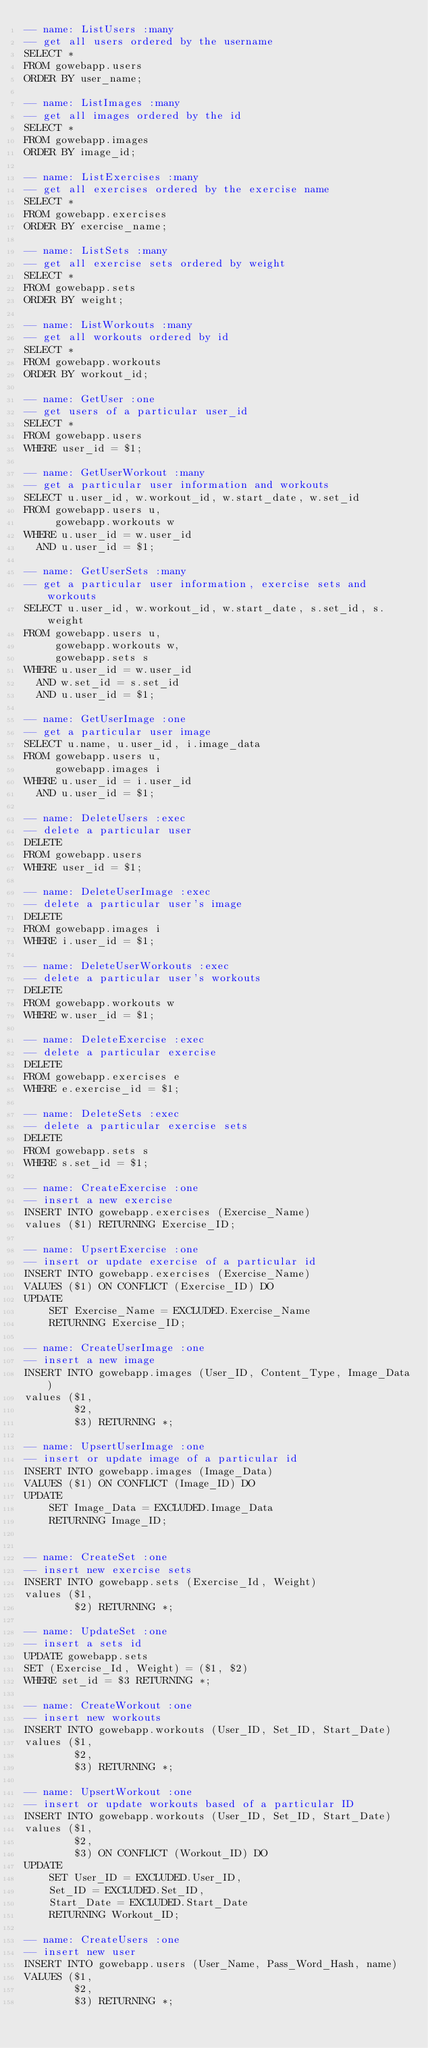Convert code to text. <code><loc_0><loc_0><loc_500><loc_500><_SQL_>-- name: ListUsers :many
-- get all users ordered by the username
SELECT *
FROM gowebapp.users
ORDER BY user_name;

-- name: ListImages :many
-- get all images ordered by the id
SELECT *
FROM gowebapp.images
ORDER BY image_id;

-- name: ListExercises :many
-- get all exercises ordered by the exercise name
SELECT *
FROM gowebapp.exercises
ORDER BY exercise_name;

-- name: ListSets :many
-- get all exercise sets ordered by weight
SELECT *
FROM gowebapp.sets
ORDER BY weight;

-- name: ListWorkouts :many
-- get all workouts ordered by id
SELECT *
FROM gowebapp.workouts
ORDER BY workout_id;

-- name: GetUser :one
-- get users of a particular user_id
SELECT *
FROM gowebapp.users
WHERE user_id = $1;

-- name: GetUserWorkout :many
-- get a particular user information and workouts
SELECT u.user_id, w.workout_id, w.start_date, w.set_id
FROM gowebapp.users u,
     gowebapp.workouts w
WHERE u.user_id = w.user_id
  AND u.user_id = $1;

-- name: GetUserSets :many
-- get a particular user information, exercise sets and workouts
SELECT u.user_id, w.workout_id, w.start_date, s.set_id, s.weight
FROM gowebapp.users u,
     gowebapp.workouts w,
     gowebapp.sets s
WHERE u.user_id = w.user_id
  AND w.set_id = s.set_id
  AND u.user_id = $1;

-- name: GetUserImage :one
-- get a particular user image
SELECT u.name, u.user_id, i.image_data
FROM gowebapp.users u,
     gowebapp.images i
WHERE u.user_id = i.user_id
  AND u.user_id = $1;

-- name: DeleteUsers :exec
-- delete a particular user
DELETE
FROM gowebapp.users
WHERE user_id = $1;

-- name: DeleteUserImage :exec
-- delete a particular user's image
DELETE
FROM gowebapp.images i
WHERE i.user_id = $1;

-- name: DeleteUserWorkouts :exec
-- delete a particular user's workouts
DELETE
FROM gowebapp.workouts w
WHERE w.user_id = $1;

-- name: DeleteExercise :exec
-- delete a particular exercise
DELETE
FROM gowebapp.exercises e
WHERE e.exercise_id = $1;

-- name: DeleteSets :exec
-- delete a particular exercise sets
DELETE
FROM gowebapp.sets s
WHERE s.set_id = $1;

-- name: CreateExercise :one
-- insert a new exercise
INSERT INTO gowebapp.exercises (Exercise_Name)
values ($1) RETURNING Exercise_ID;

-- name: UpsertExercise :one
-- insert or update exercise of a particular id
INSERT INTO gowebapp.exercises (Exercise_Name)
VALUES ($1) ON CONFLICT (Exercise_ID) DO
UPDATE
    SET Exercise_Name = EXCLUDED.Exercise_Name
    RETURNING Exercise_ID;

-- name: CreateUserImage :one
-- insert a new image
INSERT INTO gowebapp.images (User_ID, Content_Type, Image_Data)
values ($1,
        $2,
        $3) RETURNING *;

-- name: UpsertUserImage :one
-- insert or update image of a particular id
INSERT INTO gowebapp.images (Image_Data)
VALUES ($1) ON CONFLICT (Image_ID) DO
UPDATE
    SET Image_Data = EXCLUDED.Image_Data
    RETURNING Image_ID;


-- name: CreateSet :one
-- insert new exercise sets
INSERT INTO gowebapp.sets (Exercise_Id, Weight)
values ($1,
        $2) RETURNING *;

-- name: UpdateSet :one
-- insert a sets id
UPDATE gowebapp.sets
SET (Exercise_Id, Weight) = ($1, $2)
WHERE set_id = $3 RETURNING *;

-- name: CreateWorkout :one
-- insert new workouts
INSERT INTO gowebapp.workouts (User_ID, Set_ID, Start_Date)
values ($1,
        $2,
        $3) RETURNING *;

-- name: UpsertWorkout :one
-- insert or update workouts based of a particular ID
INSERT INTO gowebapp.workouts (User_ID, Set_ID, Start_Date)
values ($1,
        $2,
        $3) ON CONFLICT (Workout_ID) DO
UPDATE
    SET User_ID = EXCLUDED.User_ID,
    Set_ID = EXCLUDED.Set_ID,
    Start_Date = EXCLUDED.Start_Date
    RETURNING Workout_ID;

-- name: CreateUsers :one
-- insert new user
INSERT INTO gowebapp.users (User_Name, Pass_Word_Hash, name)
VALUES ($1,
        $2,
        $3) RETURNING *;
</code> 